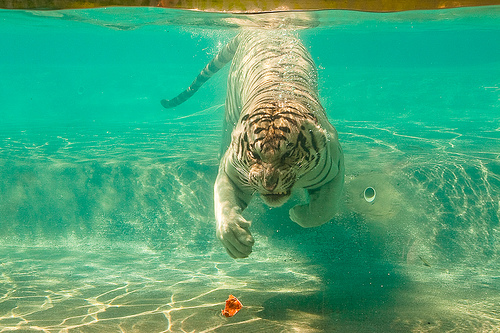<image>
Is there a tiger under the water? Yes. The tiger is positioned underneath the water, with the water above it in the vertical space. Where is the water in relation to the tiger? Is it next to the tiger? No. The water is not positioned next to the tiger. They are located in different areas of the scene. Where is the tiger in relation to the leaf? Is it in front of the leaf? No. The tiger is not in front of the leaf. The spatial positioning shows a different relationship between these objects. 